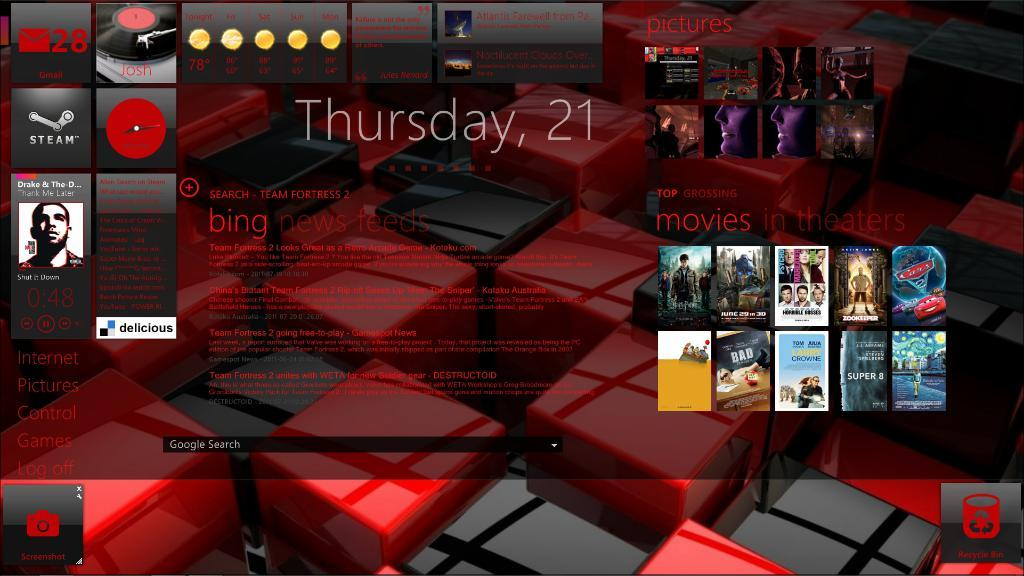What type of image is being described? The image appears to be an animation. What is located in the middle of the image? There is text in the middle of the image. What else can be seen in the image besides the text? There are images on either side of the text. How many friends are playing the game in the image? There is no game or friends present in the image; it features an animation with text and images on either side. 